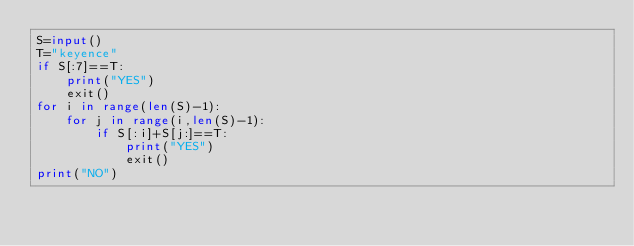Convert code to text. <code><loc_0><loc_0><loc_500><loc_500><_Python_>S=input()
T="keyence"
if S[:7]==T:
    print("YES")
    exit()
for i in range(len(S)-1):
    for j in range(i,len(S)-1):
        if S[:i]+S[j:]==T:
            print("YES")
            exit()
print("NO")</code> 